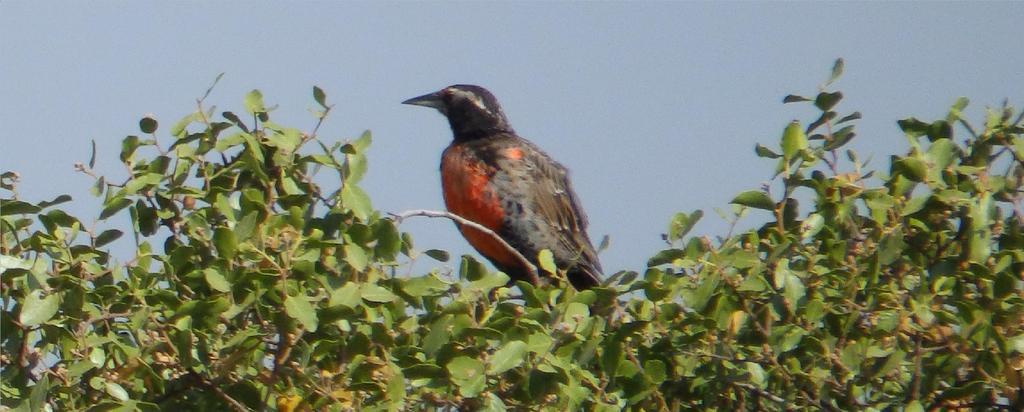Could you give a brief overview of what you see in this image? In this image we can see a bird on the tree. There is the sky at the top of the image. 